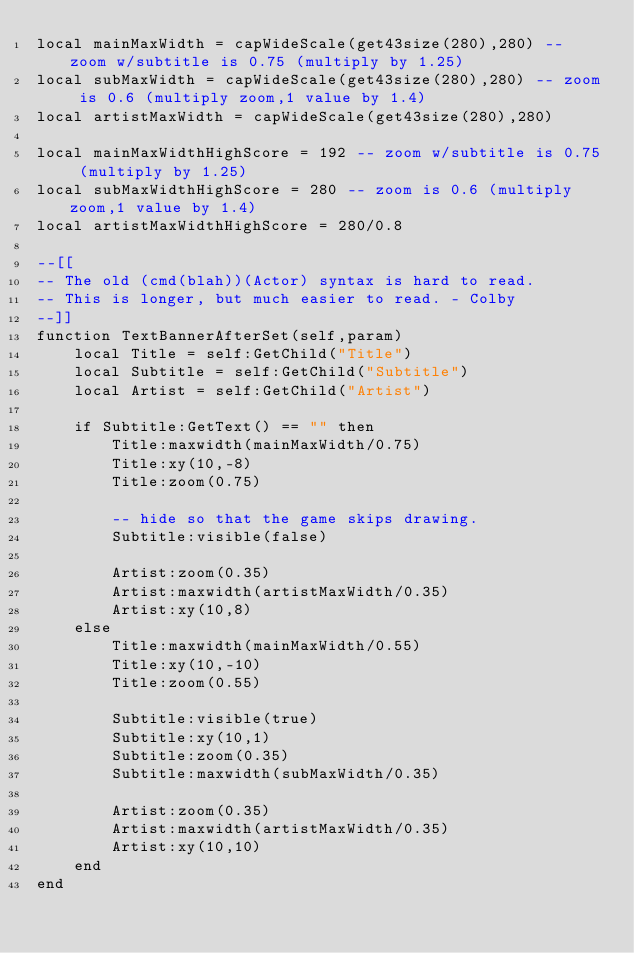<code> <loc_0><loc_0><loc_500><loc_500><_Lua_>local mainMaxWidth = capWideScale(get43size(280),280) -- zoom w/subtitle is 0.75 (multiply by 1.25)
local subMaxWidth = capWideScale(get43size(280),280) -- zoom is 0.6 (multiply zoom,1 value by 1.4)
local artistMaxWidth = capWideScale(get43size(280),280)

local mainMaxWidthHighScore = 192 -- zoom w/subtitle is 0.75 (multiply by 1.25)
local subMaxWidthHighScore = 280 -- zoom is 0.6 (multiply zoom,1 value by 1.4)
local artistMaxWidthHighScore = 280/0.8

--[[
-- The old (cmd(blah))(Actor) syntax is hard to read.
-- This is longer, but much easier to read. - Colby
--]]
function TextBannerAfterSet(self,param)
	local Title = self:GetChild("Title")
	local Subtitle = self:GetChild("Subtitle")
	local Artist = self:GetChild("Artist")
	
	if Subtitle:GetText() == "" then
		Title:maxwidth(mainMaxWidth/0.75)
		Title:xy(10,-8)
		Title:zoom(0.75)
		
		-- hide so that the game skips drawing.
		Subtitle:visible(false)

		Artist:zoom(0.35)
		Artist:maxwidth(artistMaxWidth/0.35)
		Artist:xy(10,8)
	else
		Title:maxwidth(mainMaxWidth/0.55)
		Title:xy(10,-10)
		Title:zoom(0.55)

		Subtitle:visible(true)
		Subtitle:xy(10,1)
		Subtitle:zoom(0.35)
		Subtitle:maxwidth(subMaxWidth/0.35)

		Artist:zoom(0.35)
		Artist:maxwidth(artistMaxWidth/0.35)
		Artist:xy(10,10)
	end
end
</code> 